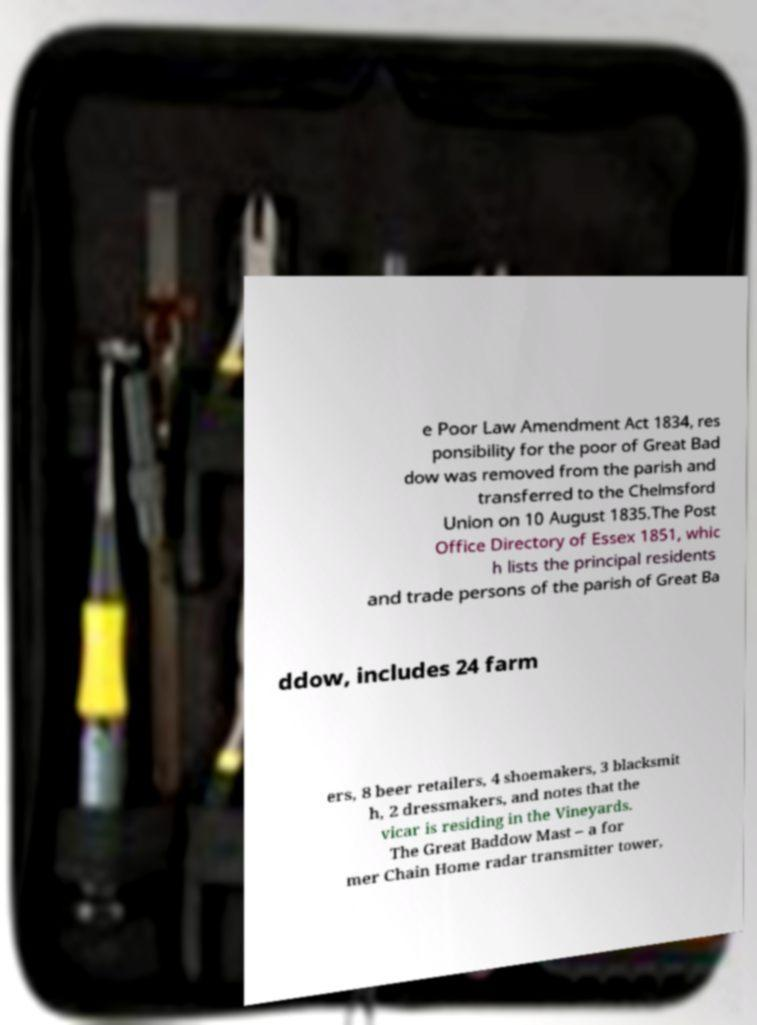What messages or text are displayed in this image? I need them in a readable, typed format. e Poor Law Amendment Act 1834, res ponsibility for the poor of Great Bad dow was removed from the parish and transferred to the Chelmsford Union on 10 August 1835.The Post Office Directory of Essex 1851, whic h lists the principal residents and trade persons of the parish of Great Ba ddow, includes 24 farm ers, 8 beer retailers, 4 shoemakers, 3 blacksmit h, 2 dressmakers, and notes that the vicar is residing in the Vineyards. The Great Baddow Mast – a for mer Chain Home radar transmitter tower, 